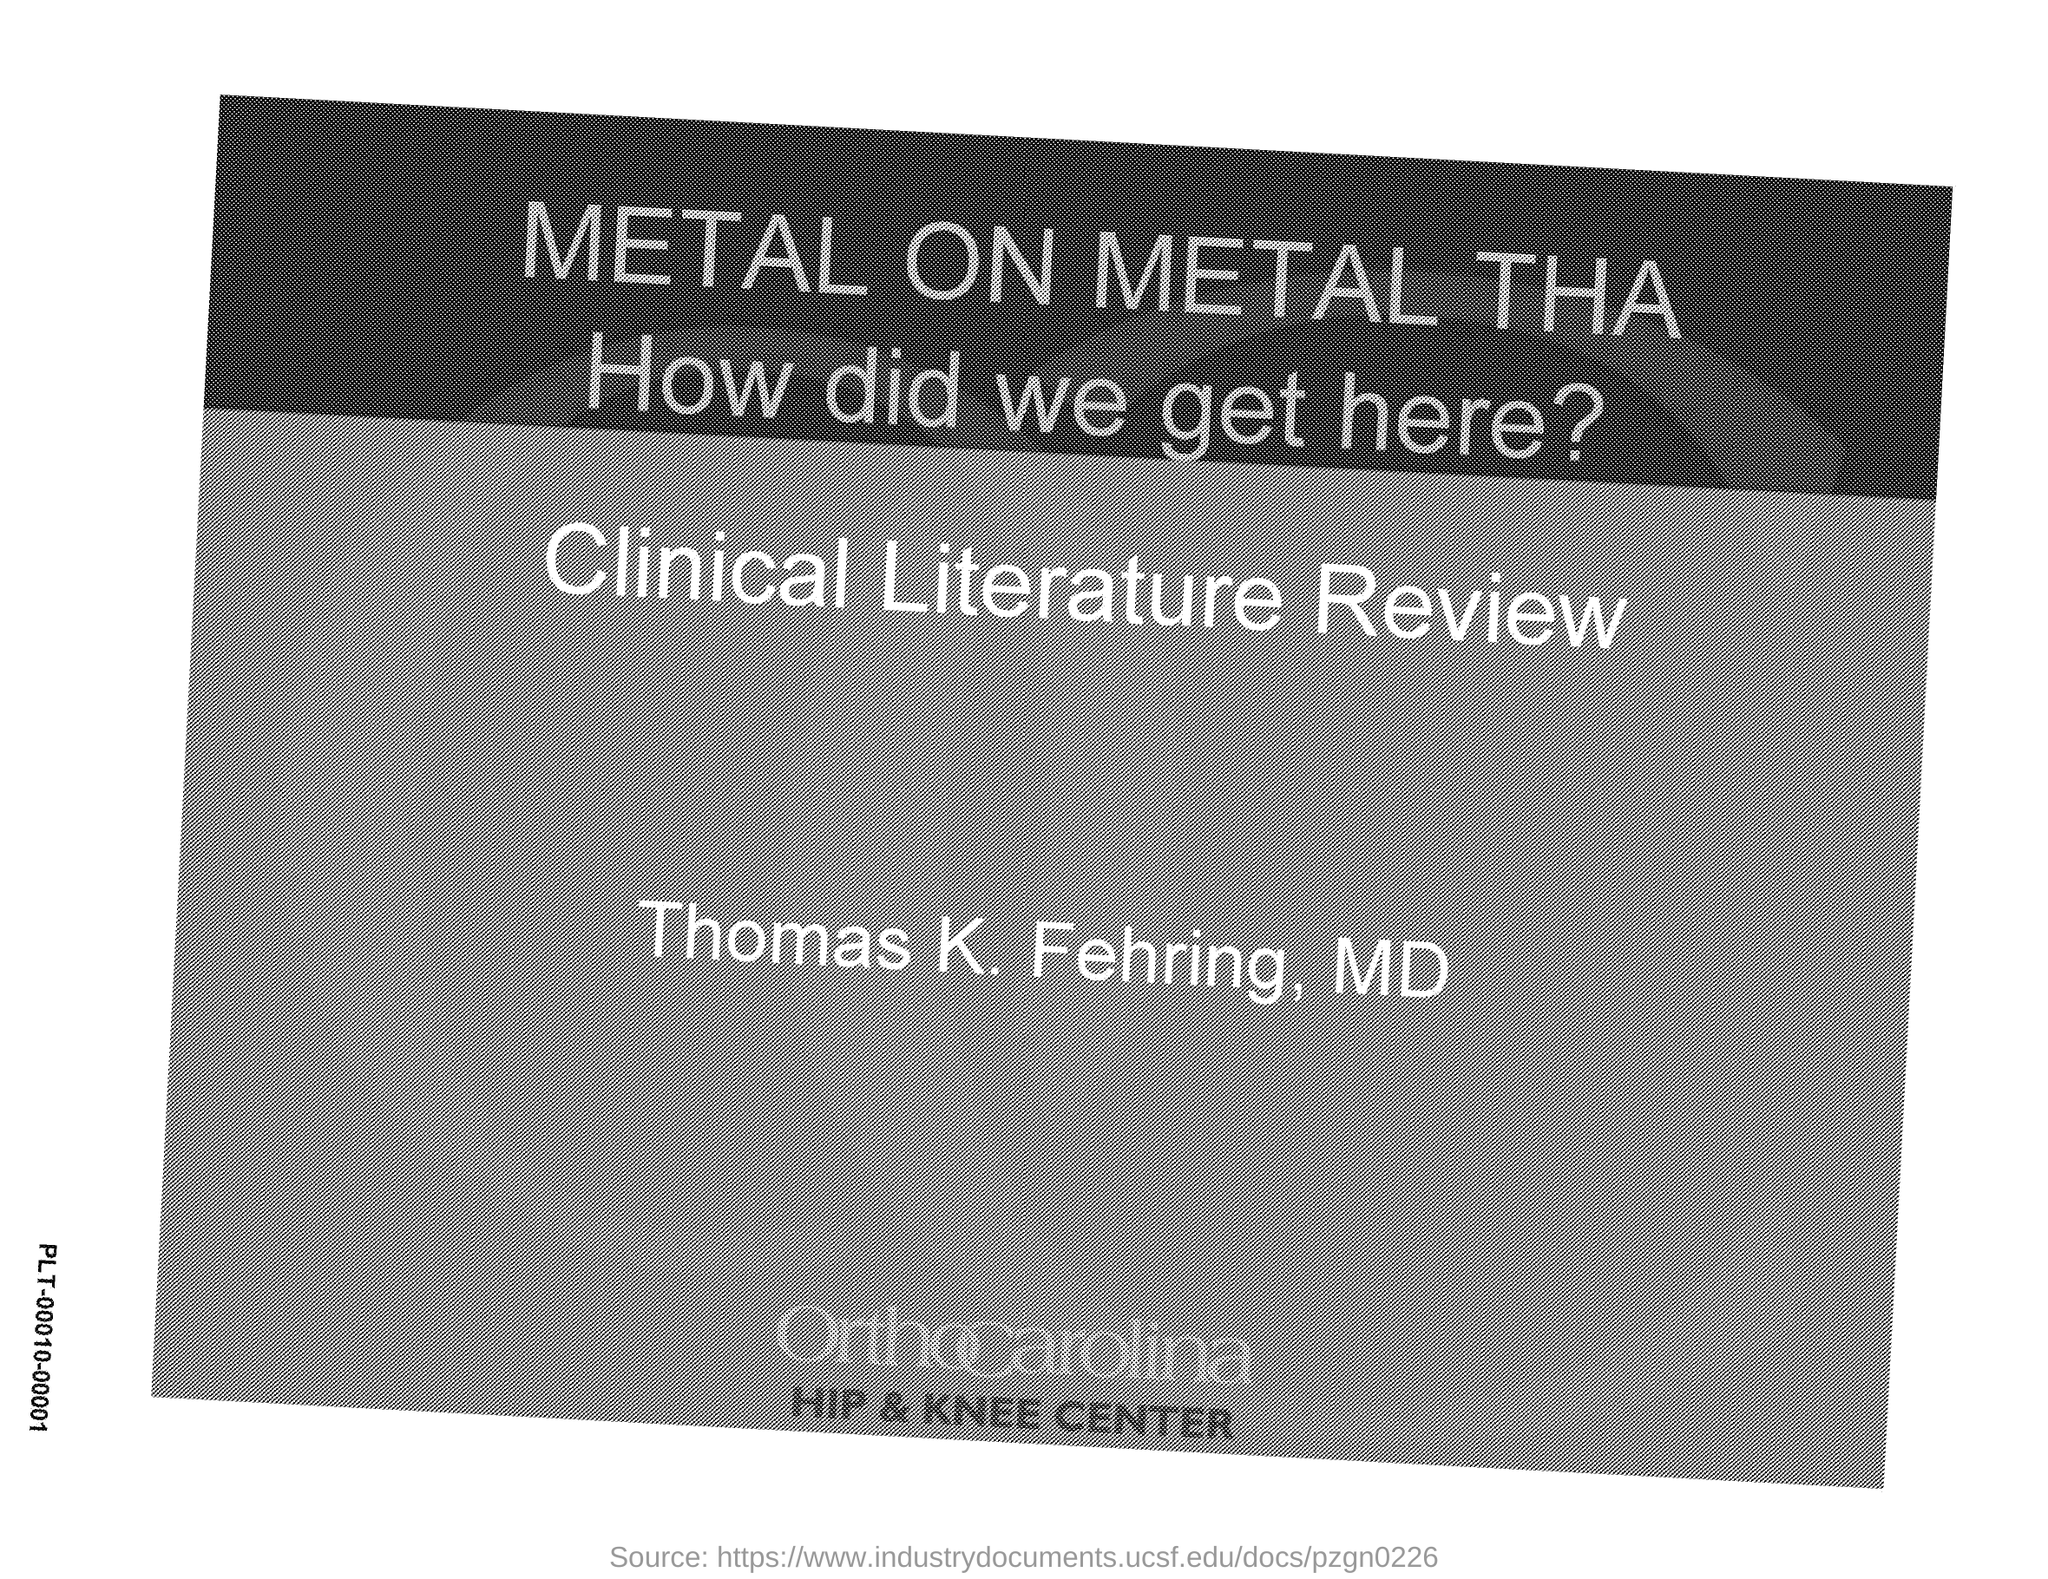What is the title of the document?
Your answer should be very brief. Metal on metal tha. 